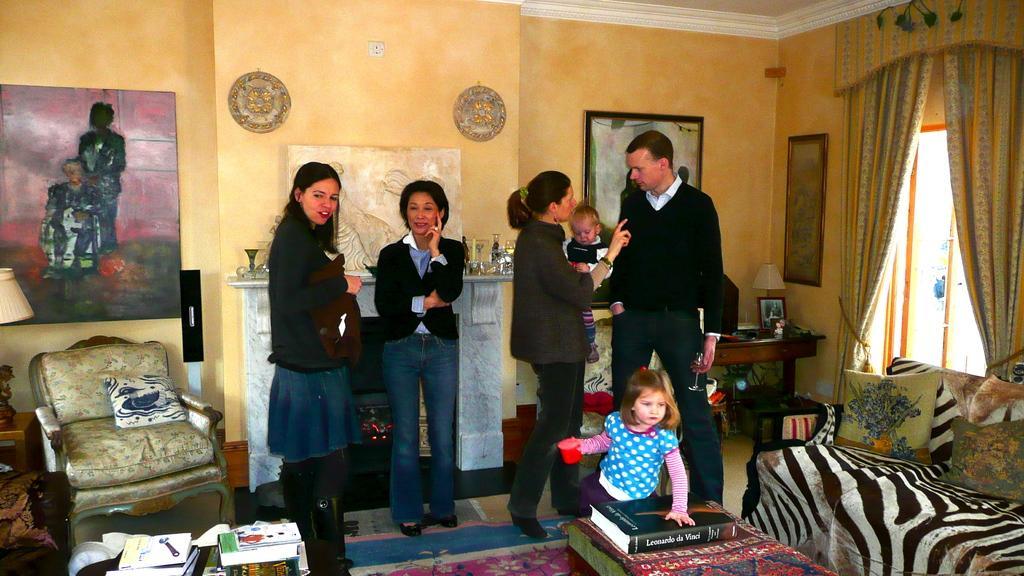How would you summarize this image in a sentence or two? In this image we can see some group of persons standing in a room, we can see couch, table on which there are some books and objects and in the background of the image there are some tables, window, curtain and there is a wall to which some paintings are attached. 